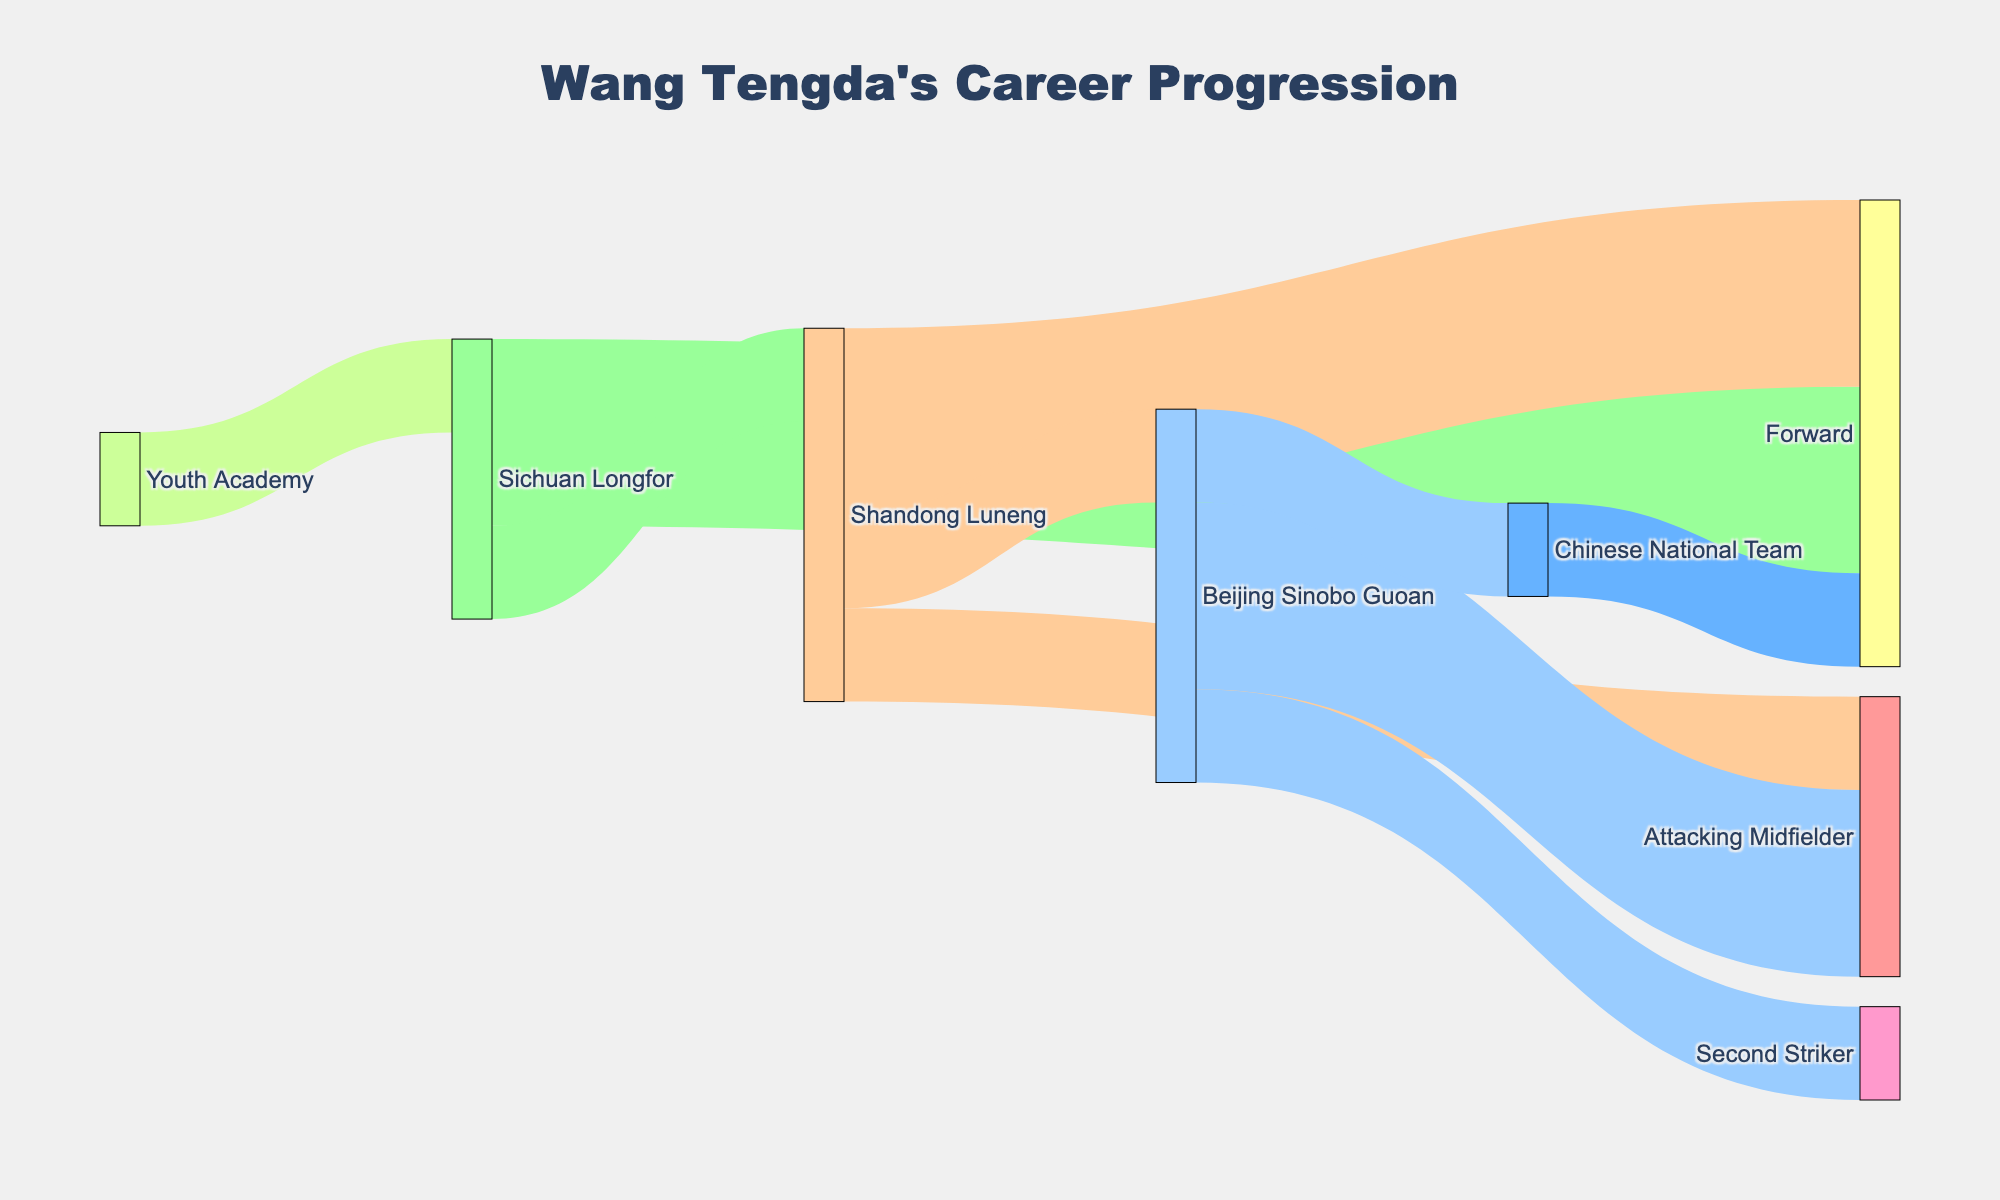How many teams has Wang Tengda played for? Look at the Sankey diagram and count distinct teams from the sources and targets. Teams include "Sichuan Longfor", "Shandong Luneng", and "Beijing Sinobo Guoan".
Answer: 3 What was Wang Tengda's first position after joining Shandong Luneng? Trace the Sankey flow from "Shandong Luneng" to the position. The first position directly linked is "Forward".
Answer: Forward How many times does Wang Tengda's career path lead to the position of Attacking Midfielder? Examine the diagram and count the flows that result in "Attacking Midfielder". There are two flows: one from "Shandong Luneng" and one from "Beijing Sinobo Guoan".
Answer: 2 Which club did Wang Tengda join after leaving Sichuan Longfor? Follow the flow from "Sichuan Longfor" to the next team. The target is "Shandong Luneng".
Answer: Shandong Luneng What role does Wang Tengda play in the Chinese National Team? Check the last target linked from the "Chinese National Team" source. The linked position is "Forward".
Answer: Forward Did Wang Tengda change his position while playing for Shandong Luneng? If yes, what positions? Look at the entries flowing from "Shandong Luneng" and check for different positions. The positions are "Forward" and "Attacking Midfielder".
Answer: Yes, Forward and Attacking Midfielder Which team did Wang Tengda join after Beijing Sinobo Guoan? Follow the source "Beijing Sinobo Guoan" to its target. The target is "Chinese National Team".
Answer: Chinese National Team How many positions has Wang Tengda played throughout his career? Count distinct positions from the targets (excluding teams). The positions include "Forward", "Attacking Midfielder", and "Second Striker".
Answer: 3 Compare the number of times Wang Tengda played as a Forward versus an Attacking Midfielder. Which position did he play more? Count the instances of each position: "Forward" appears 3 times, "Attacking Midfielder" 2 times.
Answer: Forward Trace Wang Tengda's career path starting from the Youth Academy to the national team. Follow the sequence: Youth Academy → Sichuan Longfor → Shandong Luneng → Beijing Sinobo Guoan → Chinese National Team.
Answer: Youth Academy → Sichuan Longfor → Shandong Luneng → Beijing Sinobo Guoan → Chinese National Team 